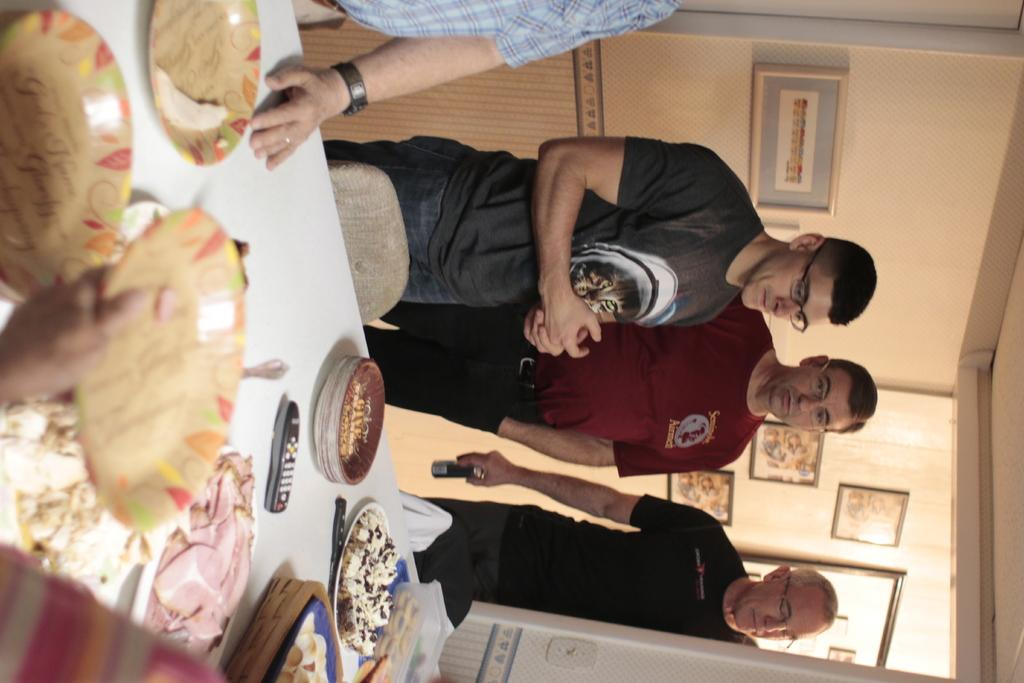What is happening in the image? There are people standing in front of a table. What is on the table? There are plates, food items, and other objects on the table. Can you describe the food items on the table? Unfortunately, the specific food items cannot be determined from the provided facts. What else can be seen in the image? There are photos on the wall. How many rabbits are sitting on the plates in the image? There are no rabbits present in the image; it features people standing in front of a table with plates and food items. What type of insect can be seen crawling on the food in the image? There is no insect present in the image; it only shows people standing in front of a table with plates and food items. 